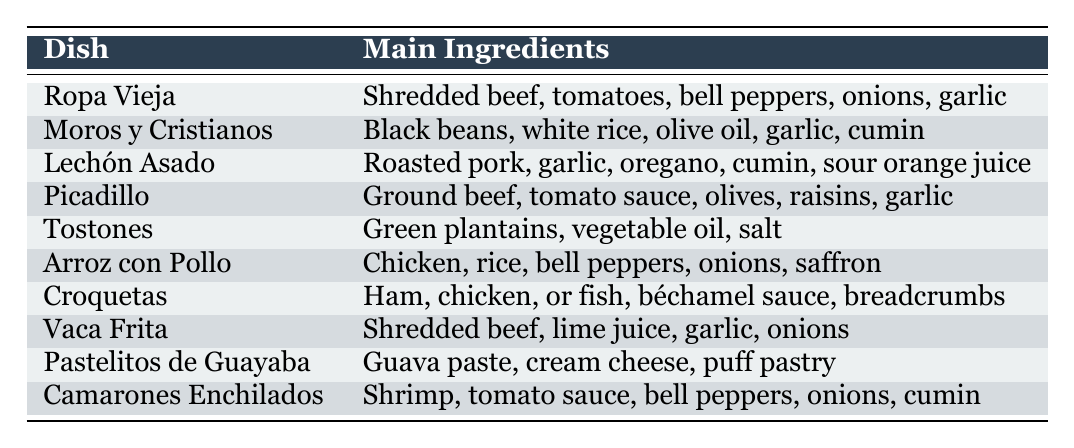What is the main ingredient of Ropa Vieja? The table lists Ropa Vieja as having "Shredded beef, tomatoes, bell peppers, onions, garlic" as its main ingredients. Focusing on the first ingredient mentioned gives us "shredded beef".
Answer: Shredded beef Which dish includes shrimp as a main ingredient? The table shows that the dish "Camarones Enchilados" has "Shrimp, tomato sauce, bell peppers, onions, cumin" as its main ingredients. Hence, shrimp is included as a main ingredient in this dish.
Answer: Camarones Enchilados How many dishes contain beef as a main ingredient? The table lists "Ropa Vieja", "Picadillo", and "Vaca Frita" as dishes that contain beef. So, we count a total of three dishes with beef.
Answer: 3 Does Tostones include onions as a main ingredient? Looking at the table, Tostones has "Green plantains, vegetable oil, salt" as its main ingredients, and there are no onions listed. Therefore, the answer is no.
Answer: No Which dish has the most ingredients listed? By examining the main ingredients for each dish, “Ropa Vieja” and “Arroz con Pollo” have five ingredients each, while others have fewer. Thus, we can conclude these two dishes have the most ingredients listed.
Answer: Ropa Vieja and Arroz con Pollo What is the main ingredient of Picadillo? The table indicates that Picadillo consists of "Ground beef, tomato sauce, olives, raisins, garlic". Therefore, the main ingredient of Picadillo is "Ground beef".
Answer: Ground beef Which dishes contain garlic as an ingredient? The dishes "Ropa Vieja", "Lechón Asado", "Picadillo", "Vaca Frita", and "Camarones Enchilados" all list garlic among their main ingredients. By counting these dishes, we find there are five.
Answer: 5 What is the difference in the number of main ingredients between Moros y Cristianos and Tostones? Moros y Cristianos has five main ingredients while Tostones has three. The difference is calculated as 5 - 3, which equals 2.
Answer: 2 Is sour orange juice a main ingredient in any dish? The table states that sour orange juice is included as a main ingredient in "Lechón Asado". Therefore, the answer is yes.
Answer: Yes Which dish uses guava paste as a main ingredient? The table shows that "Pastelitos de Guayaba" lists "Guava paste, cream cheese, puff pastry" as its main ingredients. Thus, guava paste is used in this dish.
Answer: Pastelitos de Guayaba 